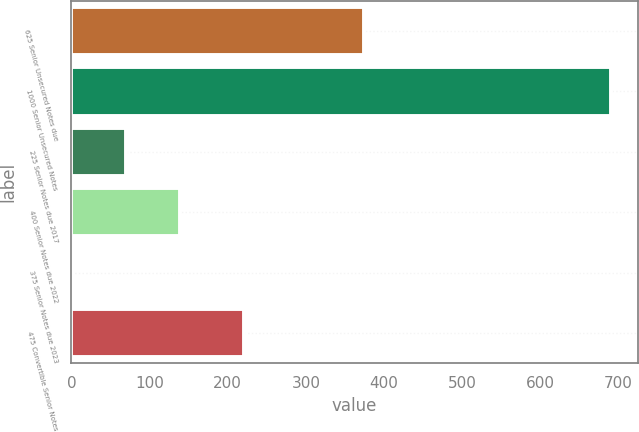Convert chart to OTSL. <chart><loc_0><loc_0><loc_500><loc_500><bar_chart><fcel>625 Senior Unsecured Notes due<fcel>1000 Senior Unsecured Notes<fcel>225 Senior Notes due 2017<fcel>400 Senior Notes due 2022<fcel>375 Senior Notes due 2023<fcel>475 Convertible Senior Notes<nl><fcel>374.5<fcel>690<fcel>69.49<fcel>138.44<fcel>0.54<fcel>220.5<nl></chart> 